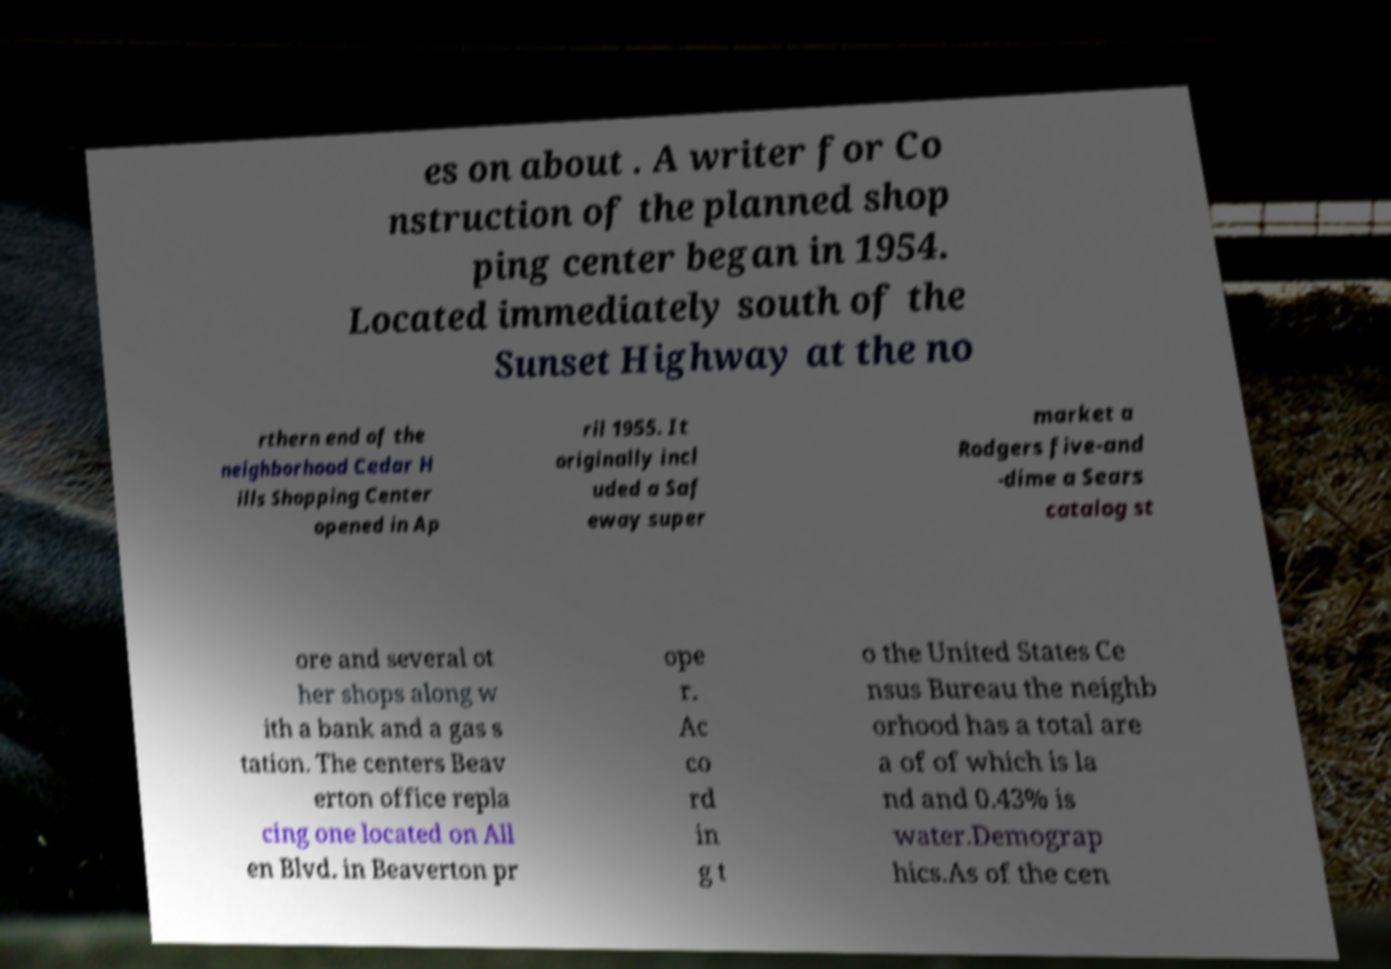Can you read and provide the text displayed in the image?This photo seems to have some interesting text. Can you extract and type it out for me? es on about . A writer for Co nstruction of the planned shop ping center began in 1954. Located immediately south of the Sunset Highway at the no rthern end of the neighborhood Cedar H ills Shopping Center opened in Ap ril 1955. It originally incl uded a Saf eway super market a Rodgers five-and -dime a Sears catalog st ore and several ot her shops along w ith a bank and a gas s tation. The centers Beav erton office repla cing one located on All en Blvd. in Beaverton pr ope r. Ac co rd in g t o the United States Ce nsus Bureau the neighb orhood has a total are a of of which is la nd and 0.43% is water.Demograp hics.As of the cen 